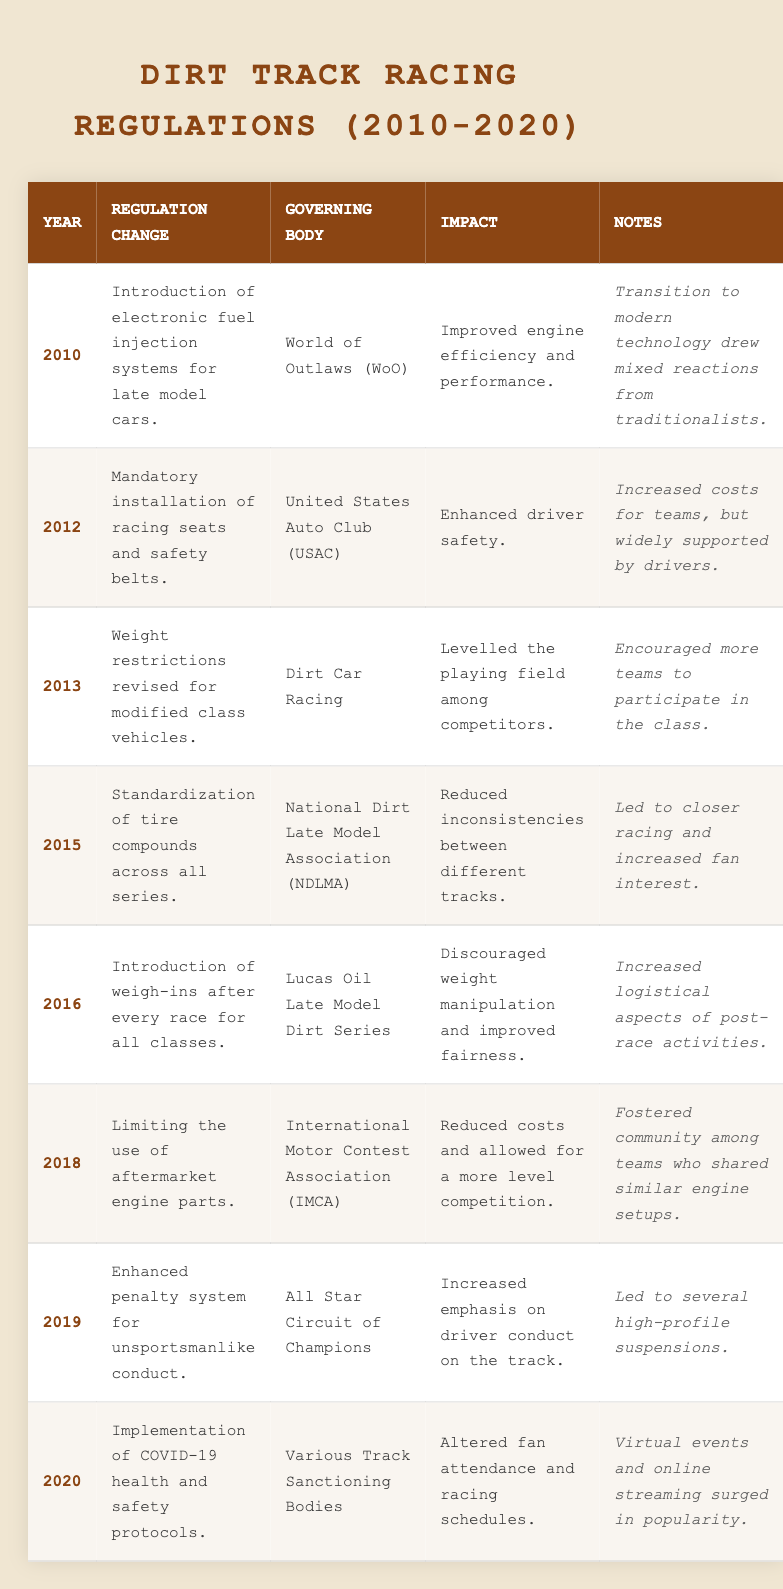What was the regulation change implemented in 2015? The table shows that in 2015, the regulation change was the standardization of tire compounds across all series.
Answer: Standardization of tire compounds Which governing body made changes in 2012? According to the table, the United States Auto Club (USAC) was the governing body that made changes in 2012.
Answer: United States Auto Club (USAC) How many regulation changes occurred between 2010 and 2020? Counting the rows in the table, there are a total of 8 regulation changes listed from 2010 to 2020.
Answer: 8 Did any regulation specifically focus on driver safety? The table indicates that the regulation change in 2012, mandatory installation of racing seats and safety belts, specifically focused on driver safety.
Answer: Yes What impact did the 2016 regulation change have? In 2016, the regulation change regarding weigh-ins after every race improved fairness by discouraging weight manipulation.
Answer: Improved fairness Which year had a regulation related to COVID-19? The table shows that the regulation related to COVID-19 health and safety protocols was implemented in 2020.
Answer: 2020 In which year did the International Motor Contest Association introduce a regulation? The table indicates that the International Motor Contest Association (IMCA) introduced a regulation change in 2018.
Answer: 2018 How did the 2015 regulation affect fan interest? According to the table, the standardization of tire compounds led to closer racing, which subsequently increased fan interest.
Answer: Increased fan interest What is the main impact of the regulation change introduced in 2013? The impact of the 2013 regulation change was to level the playing field among competitors, according to the table.
Answer: Levelled the playing field Were there any regulations focused on reducing costs for teams? Yes, as noted in the 2018 regulation change limiting the use of aftermarket engine parts, which aimed to reduce costs for teams.
Answer: Yes How many governing bodies were involved in the regulation changes listed in the table? The table lists six different governing bodies involved in the regulation changes from 2010 to 2020.
Answer: 6 